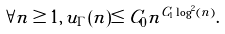Convert formula to latex. <formula><loc_0><loc_0><loc_500><loc_500>\forall n \geq 1 , \, u _ { \Gamma } ( n ) \leq C _ { 0 } n ^ { C _ { 1 } \log ^ { 2 } ( n ) } .</formula> 